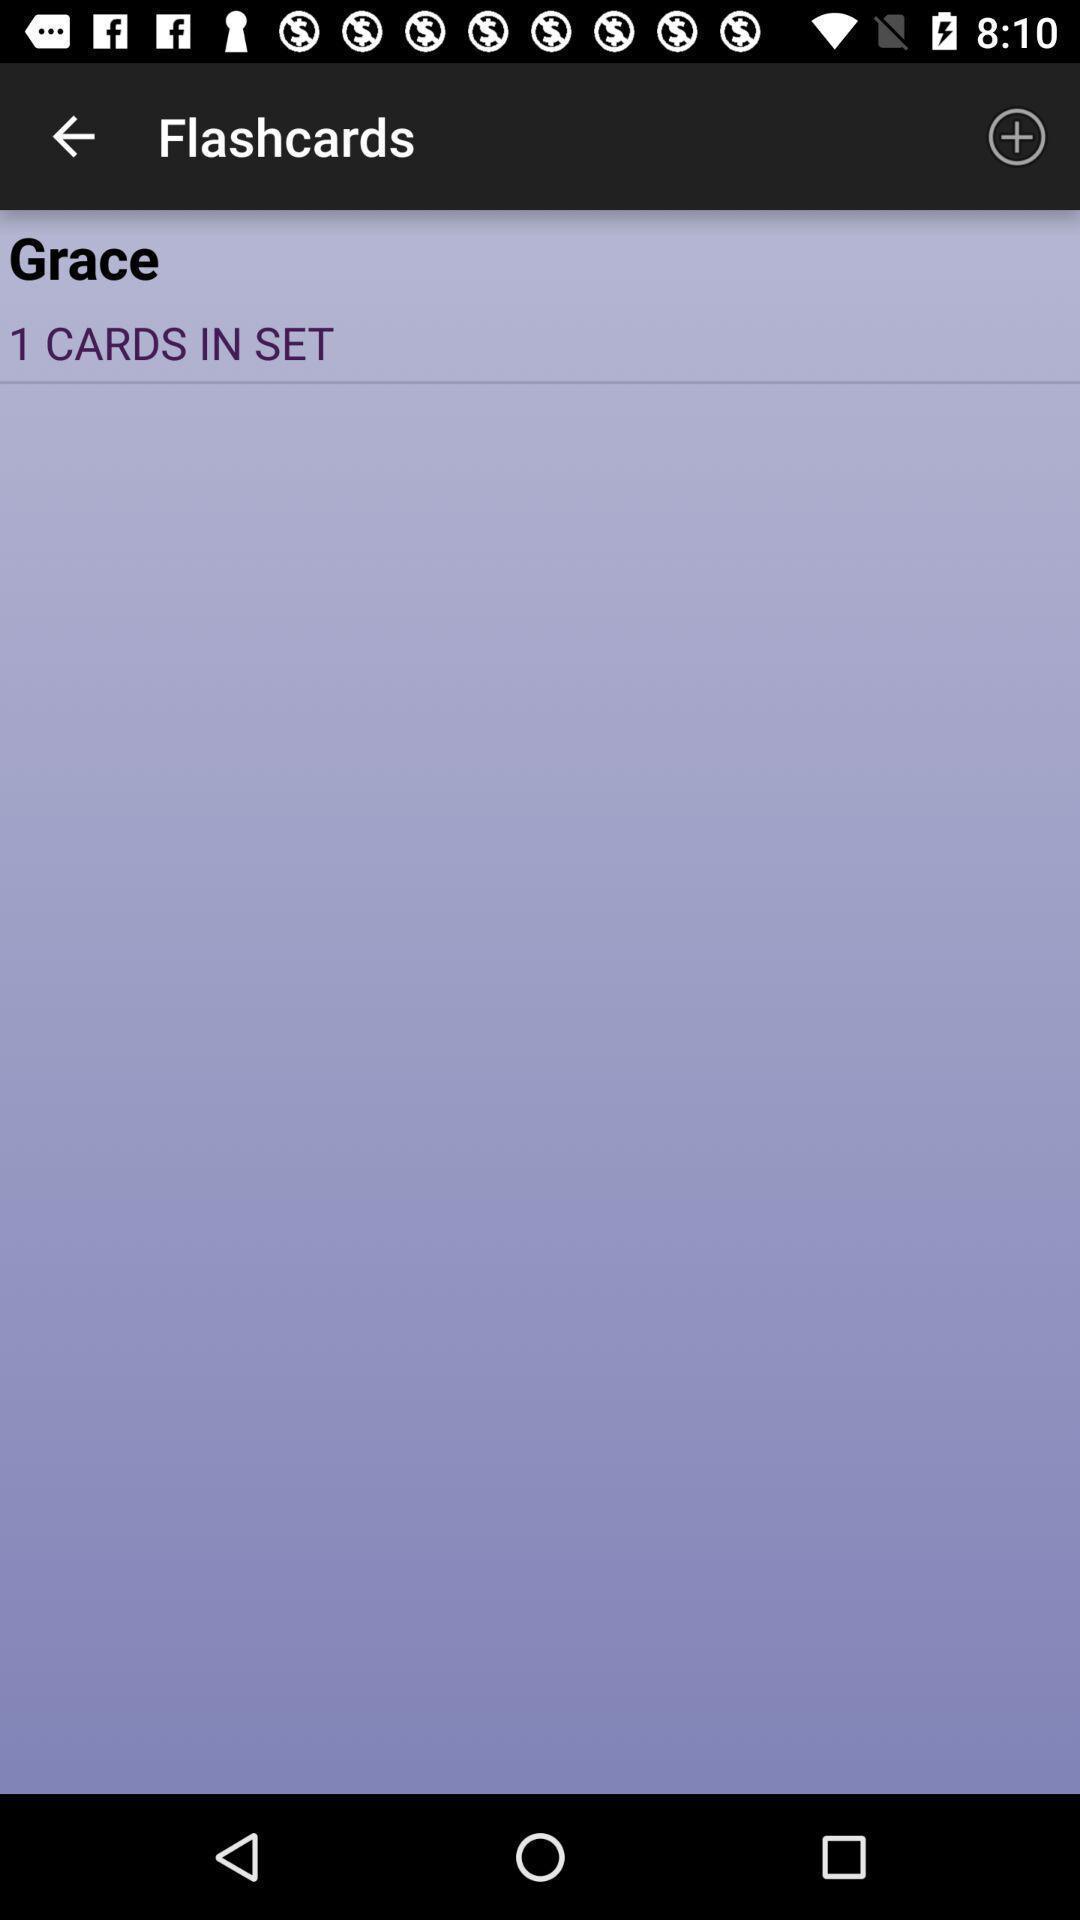Give me a summary of this screen capture. Page showing it assists studying and memorization of terms. 